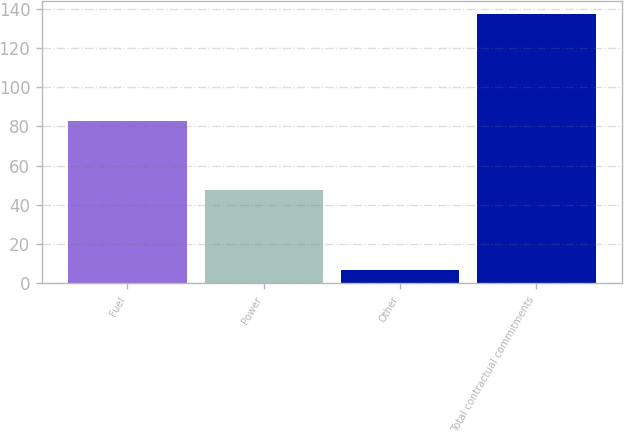Convert chart. <chart><loc_0><loc_0><loc_500><loc_500><bar_chart><fcel>Fuel<fcel>Power<fcel>Other<fcel>Total contractual commitments<nl><fcel>82.9<fcel>47.6<fcel>6.8<fcel>137.3<nl></chart> 